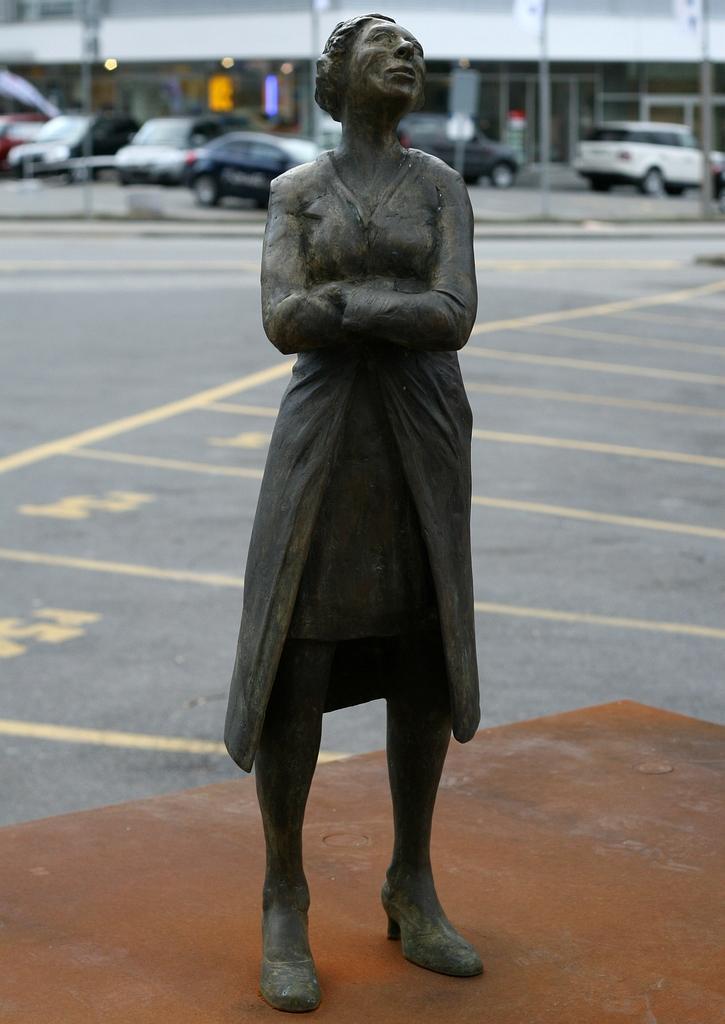How would you summarize this image in a sentence or two? In this picture we can see a statue on a platform and in the background we can see the road, vehicles, buildings, lights, poles and some objects. 